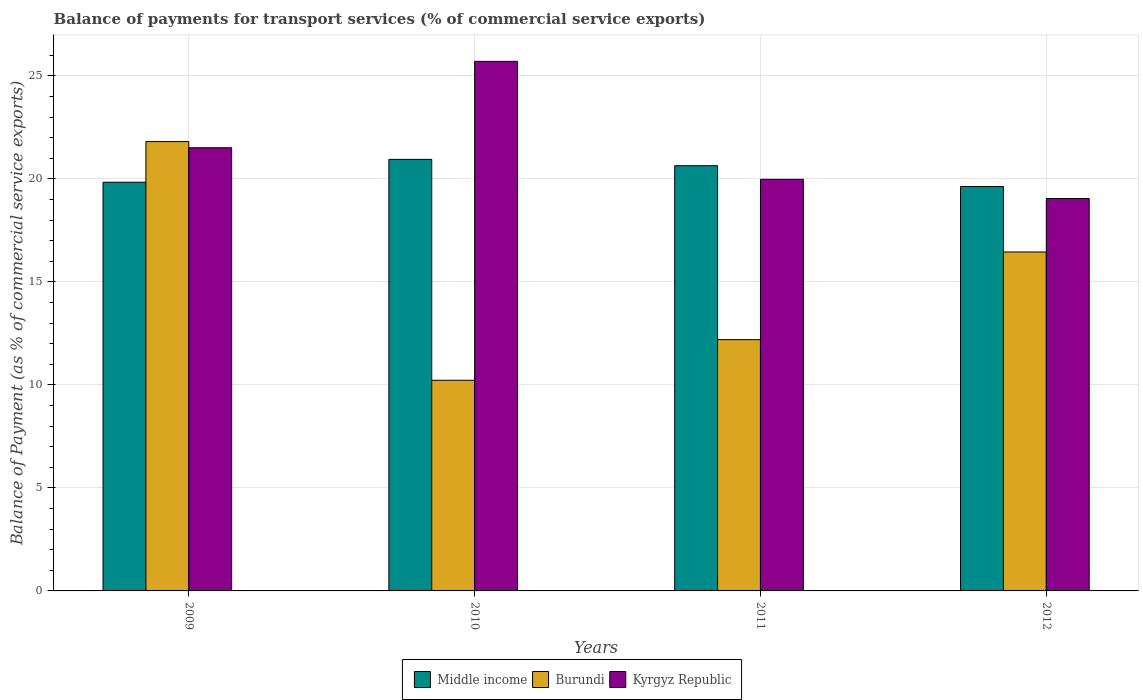How many groups of bars are there?
Your answer should be very brief. 4. How many bars are there on the 2nd tick from the right?
Offer a terse response. 3. What is the balance of payments for transport services in Kyrgyz Republic in 2011?
Make the answer very short. 19.98. Across all years, what is the maximum balance of payments for transport services in Middle income?
Your response must be concise. 20.95. Across all years, what is the minimum balance of payments for transport services in Kyrgyz Republic?
Offer a very short reply. 19.05. What is the total balance of payments for transport services in Middle income in the graph?
Your response must be concise. 81.07. What is the difference between the balance of payments for transport services in Kyrgyz Republic in 2010 and that in 2012?
Keep it short and to the point. 6.66. What is the difference between the balance of payments for transport services in Burundi in 2010 and the balance of payments for transport services in Middle income in 2012?
Your answer should be compact. -9.4. What is the average balance of payments for transport services in Burundi per year?
Give a very brief answer. 15.17. In the year 2011, what is the difference between the balance of payments for transport services in Middle income and balance of payments for transport services in Kyrgyz Republic?
Your response must be concise. 0.66. In how many years, is the balance of payments for transport services in Burundi greater than 4 %?
Provide a succinct answer. 4. What is the ratio of the balance of payments for transport services in Middle income in 2010 to that in 2011?
Your response must be concise. 1.01. Is the balance of payments for transport services in Kyrgyz Republic in 2011 less than that in 2012?
Offer a terse response. No. Is the difference between the balance of payments for transport services in Middle income in 2009 and 2012 greater than the difference between the balance of payments for transport services in Kyrgyz Republic in 2009 and 2012?
Your answer should be compact. No. What is the difference between the highest and the second highest balance of payments for transport services in Burundi?
Ensure brevity in your answer.  5.36. What is the difference between the highest and the lowest balance of payments for transport services in Middle income?
Provide a succinct answer. 1.32. In how many years, is the balance of payments for transport services in Middle income greater than the average balance of payments for transport services in Middle income taken over all years?
Provide a succinct answer. 2. What does the 2nd bar from the left in 2011 represents?
Offer a very short reply. Burundi. What does the 1st bar from the right in 2009 represents?
Your answer should be compact. Kyrgyz Republic. Is it the case that in every year, the sum of the balance of payments for transport services in Burundi and balance of payments for transport services in Middle income is greater than the balance of payments for transport services in Kyrgyz Republic?
Offer a terse response. Yes. Are all the bars in the graph horizontal?
Give a very brief answer. No. How many years are there in the graph?
Provide a short and direct response. 4. Does the graph contain any zero values?
Your answer should be compact. No. Where does the legend appear in the graph?
Your response must be concise. Bottom center. What is the title of the graph?
Your answer should be compact. Balance of payments for transport services (% of commercial service exports). What is the label or title of the Y-axis?
Offer a very short reply. Balance of Payment (as % of commercial service exports). What is the Balance of Payment (as % of commercial service exports) in Middle income in 2009?
Ensure brevity in your answer.  19.84. What is the Balance of Payment (as % of commercial service exports) of Burundi in 2009?
Keep it short and to the point. 21.82. What is the Balance of Payment (as % of commercial service exports) in Kyrgyz Republic in 2009?
Give a very brief answer. 21.52. What is the Balance of Payment (as % of commercial service exports) of Middle income in 2010?
Provide a succinct answer. 20.95. What is the Balance of Payment (as % of commercial service exports) of Burundi in 2010?
Make the answer very short. 10.23. What is the Balance of Payment (as % of commercial service exports) of Kyrgyz Republic in 2010?
Your answer should be very brief. 25.71. What is the Balance of Payment (as % of commercial service exports) in Middle income in 2011?
Your response must be concise. 20.64. What is the Balance of Payment (as % of commercial service exports) in Burundi in 2011?
Ensure brevity in your answer.  12.2. What is the Balance of Payment (as % of commercial service exports) of Kyrgyz Republic in 2011?
Offer a terse response. 19.98. What is the Balance of Payment (as % of commercial service exports) of Middle income in 2012?
Your response must be concise. 19.63. What is the Balance of Payment (as % of commercial service exports) of Burundi in 2012?
Provide a short and direct response. 16.46. What is the Balance of Payment (as % of commercial service exports) of Kyrgyz Republic in 2012?
Offer a very short reply. 19.05. Across all years, what is the maximum Balance of Payment (as % of commercial service exports) of Middle income?
Your answer should be compact. 20.95. Across all years, what is the maximum Balance of Payment (as % of commercial service exports) in Burundi?
Your response must be concise. 21.82. Across all years, what is the maximum Balance of Payment (as % of commercial service exports) of Kyrgyz Republic?
Make the answer very short. 25.71. Across all years, what is the minimum Balance of Payment (as % of commercial service exports) of Middle income?
Make the answer very short. 19.63. Across all years, what is the minimum Balance of Payment (as % of commercial service exports) of Burundi?
Offer a very short reply. 10.23. Across all years, what is the minimum Balance of Payment (as % of commercial service exports) in Kyrgyz Republic?
Provide a succinct answer. 19.05. What is the total Balance of Payment (as % of commercial service exports) of Middle income in the graph?
Provide a succinct answer. 81.07. What is the total Balance of Payment (as % of commercial service exports) in Burundi in the graph?
Ensure brevity in your answer.  60.7. What is the total Balance of Payment (as % of commercial service exports) of Kyrgyz Republic in the graph?
Provide a succinct answer. 86.26. What is the difference between the Balance of Payment (as % of commercial service exports) of Middle income in 2009 and that in 2010?
Ensure brevity in your answer.  -1.11. What is the difference between the Balance of Payment (as % of commercial service exports) of Burundi in 2009 and that in 2010?
Keep it short and to the point. 11.59. What is the difference between the Balance of Payment (as % of commercial service exports) of Kyrgyz Republic in 2009 and that in 2010?
Your answer should be compact. -4.19. What is the difference between the Balance of Payment (as % of commercial service exports) of Middle income in 2009 and that in 2011?
Keep it short and to the point. -0.8. What is the difference between the Balance of Payment (as % of commercial service exports) of Burundi in 2009 and that in 2011?
Offer a very short reply. 9.62. What is the difference between the Balance of Payment (as % of commercial service exports) in Kyrgyz Republic in 2009 and that in 2011?
Ensure brevity in your answer.  1.53. What is the difference between the Balance of Payment (as % of commercial service exports) in Middle income in 2009 and that in 2012?
Give a very brief answer. 0.21. What is the difference between the Balance of Payment (as % of commercial service exports) in Burundi in 2009 and that in 2012?
Your answer should be compact. 5.36. What is the difference between the Balance of Payment (as % of commercial service exports) of Kyrgyz Republic in 2009 and that in 2012?
Provide a succinct answer. 2.47. What is the difference between the Balance of Payment (as % of commercial service exports) of Middle income in 2010 and that in 2011?
Give a very brief answer. 0.31. What is the difference between the Balance of Payment (as % of commercial service exports) in Burundi in 2010 and that in 2011?
Offer a very short reply. -1.97. What is the difference between the Balance of Payment (as % of commercial service exports) of Kyrgyz Republic in 2010 and that in 2011?
Offer a terse response. 5.73. What is the difference between the Balance of Payment (as % of commercial service exports) of Middle income in 2010 and that in 2012?
Make the answer very short. 1.32. What is the difference between the Balance of Payment (as % of commercial service exports) in Burundi in 2010 and that in 2012?
Provide a succinct answer. -6.23. What is the difference between the Balance of Payment (as % of commercial service exports) in Kyrgyz Republic in 2010 and that in 2012?
Give a very brief answer. 6.66. What is the difference between the Balance of Payment (as % of commercial service exports) of Burundi in 2011 and that in 2012?
Give a very brief answer. -4.26. What is the difference between the Balance of Payment (as % of commercial service exports) of Kyrgyz Republic in 2011 and that in 2012?
Provide a succinct answer. 0.93. What is the difference between the Balance of Payment (as % of commercial service exports) of Middle income in 2009 and the Balance of Payment (as % of commercial service exports) of Burundi in 2010?
Offer a very short reply. 9.61. What is the difference between the Balance of Payment (as % of commercial service exports) in Middle income in 2009 and the Balance of Payment (as % of commercial service exports) in Kyrgyz Republic in 2010?
Your answer should be very brief. -5.87. What is the difference between the Balance of Payment (as % of commercial service exports) in Burundi in 2009 and the Balance of Payment (as % of commercial service exports) in Kyrgyz Republic in 2010?
Ensure brevity in your answer.  -3.89. What is the difference between the Balance of Payment (as % of commercial service exports) of Middle income in 2009 and the Balance of Payment (as % of commercial service exports) of Burundi in 2011?
Ensure brevity in your answer.  7.64. What is the difference between the Balance of Payment (as % of commercial service exports) of Middle income in 2009 and the Balance of Payment (as % of commercial service exports) of Kyrgyz Republic in 2011?
Make the answer very short. -0.14. What is the difference between the Balance of Payment (as % of commercial service exports) in Burundi in 2009 and the Balance of Payment (as % of commercial service exports) in Kyrgyz Republic in 2011?
Give a very brief answer. 1.83. What is the difference between the Balance of Payment (as % of commercial service exports) in Middle income in 2009 and the Balance of Payment (as % of commercial service exports) in Burundi in 2012?
Ensure brevity in your answer.  3.39. What is the difference between the Balance of Payment (as % of commercial service exports) of Middle income in 2009 and the Balance of Payment (as % of commercial service exports) of Kyrgyz Republic in 2012?
Give a very brief answer. 0.79. What is the difference between the Balance of Payment (as % of commercial service exports) of Burundi in 2009 and the Balance of Payment (as % of commercial service exports) of Kyrgyz Republic in 2012?
Ensure brevity in your answer.  2.77. What is the difference between the Balance of Payment (as % of commercial service exports) of Middle income in 2010 and the Balance of Payment (as % of commercial service exports) of Burundi in 2011?
Give a very brief answer. 8.75. What is the difference between the Balance of Payment (as % of commercial service exports) of Middle income in 2010 and the Balance of Payment (as % of commercial service exports) of Kyrgyz Republic in 2011?
Provide a short and direct response. 0.97. What is the difference between the Balance of Payment (as % of commercial service exports) in Burundi in 2010 and the Balance of Payment (as % of commercial service exports) in Kyrgyz Republic in 2011?
Your response must be concise. -9.76. What is the difference between the Balance of Payment (as % of commercial service exports) in Middle income in 2010 and the Balance of Payment (as % of commercial service exports) in Burundi in 2012?
Provide a short and direct response. 4.5. What is the difference between the Balance of Payment (as % of commercial service exports) in Middle income in 2010 and the Balance of Payment (as % of commercial service exports) in Kyrgyz Republic in 2012?
Provide a short and direct response. 1.9. What is the difference between the Balance of Payment (as % of commercial service exports) of Burundi in 2010 and the Balance of Payment (as % of commercial service exports) of Kyrgyz Republic in 2012?
Provide a short and direct response. -8.82. What is the difference between the Balance of Payment (as % of commercial service exports) of Middle income in 2011 and the Balance of Payment (as % of commercial service exports) of Burundi in 2012?
Provide a succinct answer. 4.19. What is the difference between the Balance of Payment (as % of commercial service exports) in Middle income in 2011 and the Balance of Payment (as % of commercial service exports) in Kyrgyz Republic in 2012?
Give a very brief answer. 1.59. What is the difference between the Balance of Payment (as % of commercial service exports) of Burundi in 2011 and the Balance of Payment (as % of commercial service exports) of Kyrgyz Republic in 2012?
Give a very brief answer. -6.85. What is the average Balance of Payment (as % of commercial service exports) of Middle income per year?
Ensure brevity in your answer.  20.27. What is the average Balance of Payment (as % of commercial service exports) in Burundi per year?
Offer a very short reply. 15.17. What is the average Balance of Payment (as % of commercial service exports) of Kyrgyz Republic per year?
Keep it short and to the point. 21.56. In the year 2009, what is the difference between the Balance of Payment (as % of commercial service exports) in Middle income and Balance of Payment (as % of commercial service exports) in Burundi?
Give a very brief answer. -1.97. In the year 2009, what is the difference between the Balance of Payment (as % of commercial service exports) of Middle income and Balance of Payment (as % of commercial service exports) of Kyrgyz Republic?
Ensure brevity in your answer.  -1.67. In the year 2009, what is the difference between the Balance of Payment (as % of commercial service exports) in Burundi and Balance of Payment (as % of commercial service exports) in Kyrgyz Republic?
Give a very brief answer. 0.3. In the year 2010, what is the difference between the Balance of Payment (as % of commercial service exports) in Middle income and Balance of Payment (as % of commercial service exports) in Burundi?
Offer a very short reply. 10.72. In the year 2010, what is the difference between the Balance of Payment (as % of commercial service exports) in Middle income and Balance of Payment (as % of commercial service exports) in Kyrgyz Republic?
Provide a short and direct response. -4.76. In the year 2010, what is the difference between the Balance of Payment (as % of commercial service exports) in Burundi and Balance of Payment (as % of commercial service exports) in Kyrgyz Republic?
Offer a terse response. -15.48. In the year 2011, what is the difference between the Balance of Payment (as % of commercial service exports) of Middle income and Balance of Payment (as % of commercial service exports) of Burundi?
Give a very brief answer. 8.44. In the year 2011, what is the difference between the Balance of Payment (as % of commercial service exports) in Middle income and Balance of Payment (as % of commercial service exports) in Kyrgyz Republic?
Your answer should be very brief. 0.66. In the year 2011, what is the difference between the Balance of Payment (as % of commercial service exports) of Burundi and Balance of Payment (as % of commercial service exports) of Kyrgyz Republic?
Ensure brevity in your answer.  -7.78. In the year 2012, what is the difference between the Balance of Payment (as % of commercial service exports) of Middle income and Balance of Payment (as % of commercial service exports) of Burundi?
Your response must be concise. 3.18. In the year 2012, what is the difference between the Balance of Payment (as % of commercial service exports) in Middle income and Balance of Payment (as % of commercial service exports) in Kyrgyz Republic?
Offer a very short reply. 0.58. In the year 2012, what is the difference between the Balance of Payment (as % of commercial service exports) of Burundi and Balance of Payment (as % of commercial service exports) of Kyrgyz Republic?
Ensure brevity in your answer.  -2.59. What is the ratio of the Balance of Payment (as % of commercial service exports) in Middle income in 2009 to that in 2010?
Your answer should be compact. 0.95. What is the ratio of the Balance of Payment (as % of commercial service exports) of Burundi in 2009 to that in 2010?
Offer a very short reply. 2.13. What is the ratio of the Balance of Payment (as % of commercial service exports) in Kyrgyz Republic in 2009 to that in 2010?
Provide a short and direct response. 0.84. What is the ratio of the Balance of Payment (as % of commercial service exports) of Middle income in 2009 to that in 2011?
Make the answer very short. 0.96. What is the ratio of the Balance of Payment (as % of commercial service exports) of Burundi in 2009 to that in 2011?
Ensure brevity in your answer.  1.79. What is the ratio of the Balance of Payment (as % of commercial service exports) of Kyrgyz Republic in 2009 to that in 2011?
Make the answer very short. 1.08. What is the ratio of the Balance of Payment (as % of commercial service exports) in Middle income in 2009 to that in 2012?
Provide a succinct answer. 1.01. What is the ratio of the Balance of Payment (as % of commercial service exports) of Burundi in 2009 to that in 2012?
Your response must be concise. 1.33. What is the ratio of the Balance of Payment (as % of commercial service exports) in Kyrgyz Republic in 2009 to that in 2012?
Give a very brief answer. 1.13. What is the ratio of the Balance of Payment (as % of commercial service exports) in Middle income in 2010 to that in 2011?
Make the answer very short. 1.01. What is the ratio of the Balance of Payment (as % of commercial service exports) in Burundi in 2010 to that in 2011?
Keep it short and to the point. 0.84. What is the ratio of the Balance of Payment (as % of commercial service exports) of Kyrgyz Republic in 2010 to that in 2011?
Provide a short and direct response. 1.29. What is the ratio of the Balance of Payment (as % of commercial service exports) of Middle income in 2010 to that in 2012?
Keep it short and to the point. 1.07. What is the ratio of the Balance of Payment (as % of commercial service exports) in Burundi in 2010 to that in 2012?
Your answer should be very brief. 0.62. What is the ratio of the Balance of Payment (as % of commercial service exports) of Kyrgyz Republic in 2010 to that in 2012?
Make the answer very short. 1.35. What is the ratio of the Balance of Payment (as % of commercial service exports) of Middle income in 2011 to that in 2012?
Your answer should be very brief. 1.05. What is the ratio of the Balance of Payment (as % of commercial service exports) of Burundi in 2011 to that in 2012?
Provide a short and direct response. 0.74. What is the ratio of the Balance of Payment (as % of commercial service exports) in Kyrgyz Republic in 2011 to that in 2012?
Provide a succinct answer. 1.05. What is the difference between the highest and the second highest Balance of Payment (as % of commercial service exports) of Middle income?
Your answer should be very brief. 0.31. What is the difference between the highest and the second highest Balance of Payment (as % of commercial service exports) of Burundi?
Provide a short and direct response. 5.36. What is the difference between the highest and the second highest Balance of Payment (as % of commercial service exports) of Kyrgyz Republic?
Give a very brief answer. 4.19. What is the difference between the highest and the lowest Balance of Payment (as % of commercial service exports) of Middle income?
Your answer should be compact. 1.32. What is the difference between the highest and the lowest Balance of Payment (as % of commercial service exports) in Burundi?
Your response must be concise. 11.59. What is the difference between the highest and the lowest Balance of Payment (as % of commercial service exports) in Kyrgyz Republic?
Make the answer very short. 6.66. 